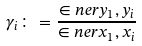Convert formula to latex. <formula><loc_0><loc_0><loc_500><loc_500>\gamma _ { i } \colon = \frac { \in n e r { y _ { 1 } , y _ { i } } } { \in n e r { x _ { 1 } , x _ { i } } }</formula> 